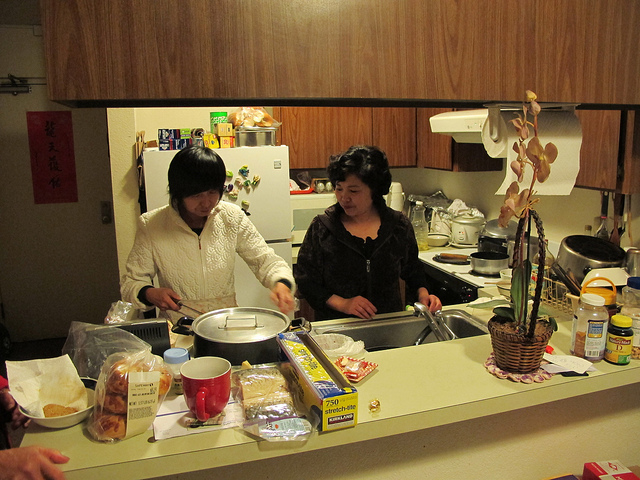<image>What food is being made? I don't know what food is being made. However, it could be pizza, chili, chicken, Italian, Chinese, or rice. What food is being made? I don't know what food is being made in the image. It can be either dinner, pizza, chili, chicken, Italian, Chinese, or rice. 